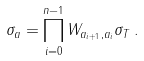Convert formula to latex. <formula><loc_0><loc_0><loc_500><loc_500>\sigma _ { a } = \prod _ { i = 0 } ^ { n - 1 } W _ { a _ { i + 1 } , a _ { i } } \sigma _ { T } \, .</formula> 